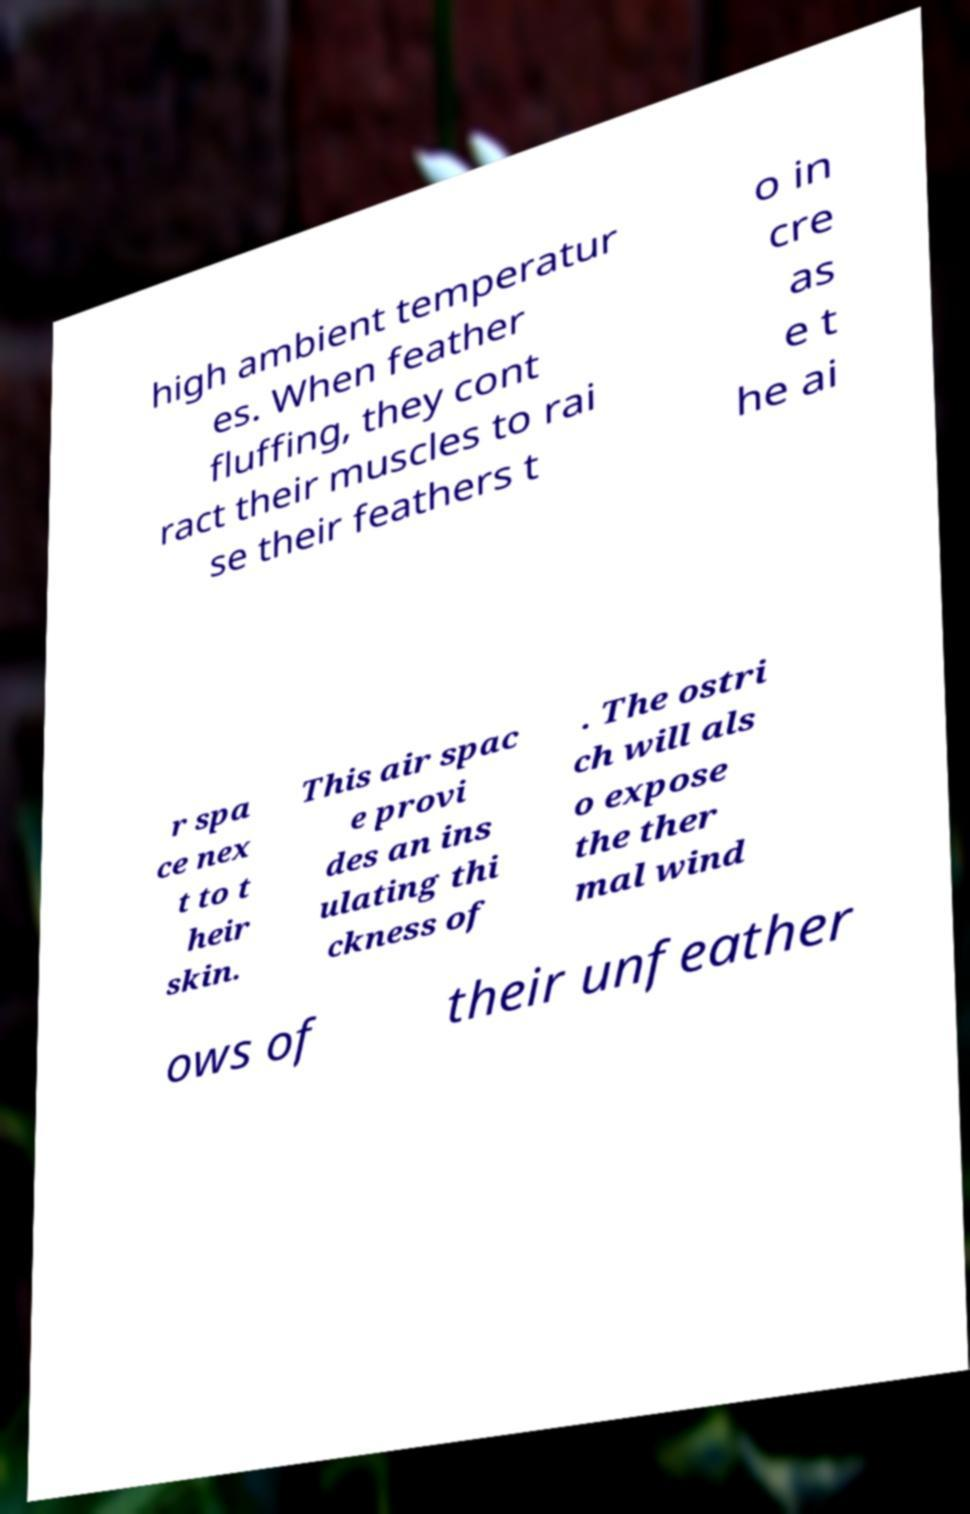Can you accurately transcribe the text from the provided image for me? high ambient temperatur es. When feather fluffing, they cont ract their muscles to rai se their feathers t o in cre as e t he ai r spa ce nex t to t heir skin. This air spac e provi des an ins ulating thi ckness of . The ostri ch will als o expose the ther mal wind ows of their unfeather 